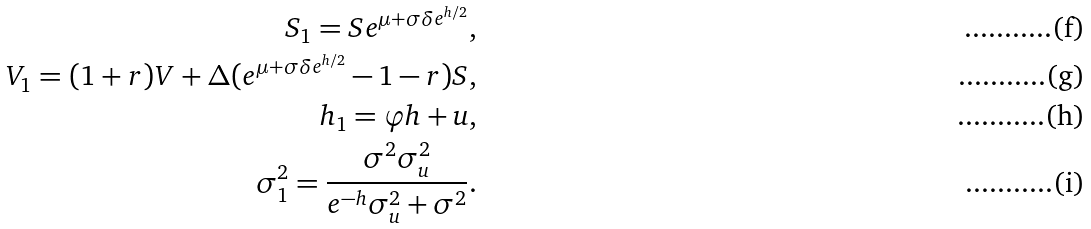<formula> <loc_0><loc_0><loc_500><loc_500>S _ { 1 } = S e ^ { \mu + \sigma \delta e ^ { h / 2 } } , \\ V _ { 1 } = ( 1 + r ) V + \Delta ( e ^ { \mu + \sigma \delta e ^ { h / 2 } } - 1 - r ) S , \\ h _ { 1 } = \varphi h + u , \\ \sigma _ { 1 } ^ { 2 } = \frac { \sigma ^ { 2 } \sigma _ { u } ^ { 2 } } { e ^ { - h } \sigma _ { u } ^ { 2 } + \sigma ^ { 2 } } .</formula> 